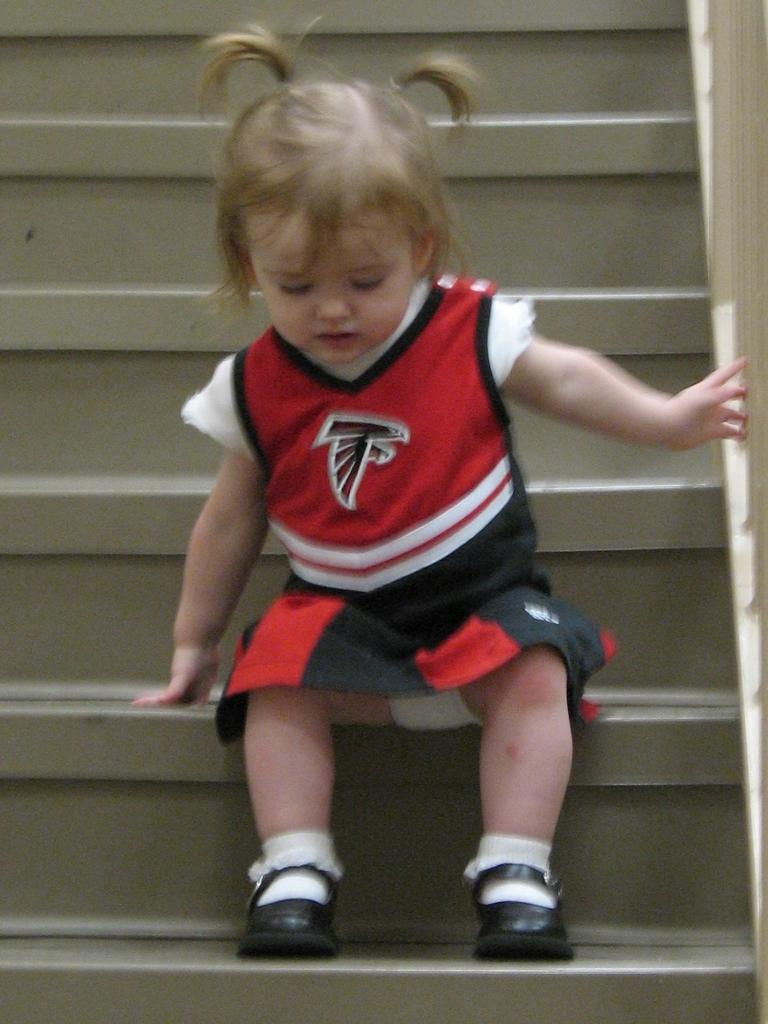What is the main subject of the picture? The main subject of the picture is a kid. What is the kid wearing? The kid is wearing a red dress. Where is the kid sitting? The kid is sitting on a staircase. What can be seen on the right side of the image? There is railing on the right side of the image. What type of bone can be seen in the kid's hand in the image? There is no bone visible in the kid's hand or anywhere else in the image. What educational institution is the kid attending in the image? The image does not provide any information about the kid's education or the presence of an educational institution. 